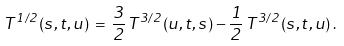<formula> <loc_0><loc_0><loc_500><loc_500>T ^ { 1 / 2 } ( s , t , u ) \, = \, \frac { 3 } { 2 } \, T ^ { 3 / 2 } ( u , t , s ) - \frac { 1 } { 2 } \, T ^ { 3 / 2 } ( s , t , u ) \, .</formula> 